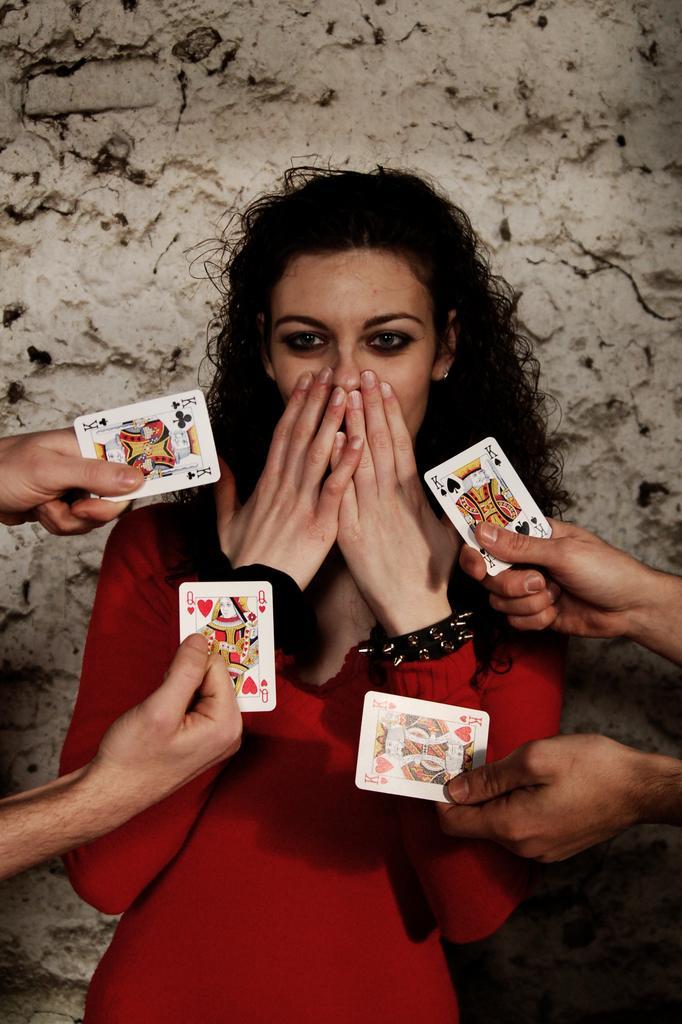How would you summarize this image in a sentence or two? In this image I see a woman who is wearing a red colored dress and she is covering her mouth with both the hands and on the either sides we see 2 hands holding the playing cards. 